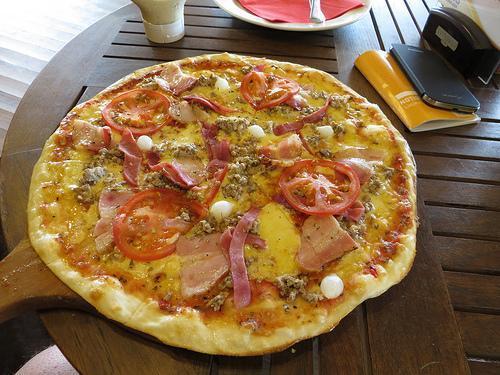How many pizza pies are there?
Give a very brief answer. 1. 